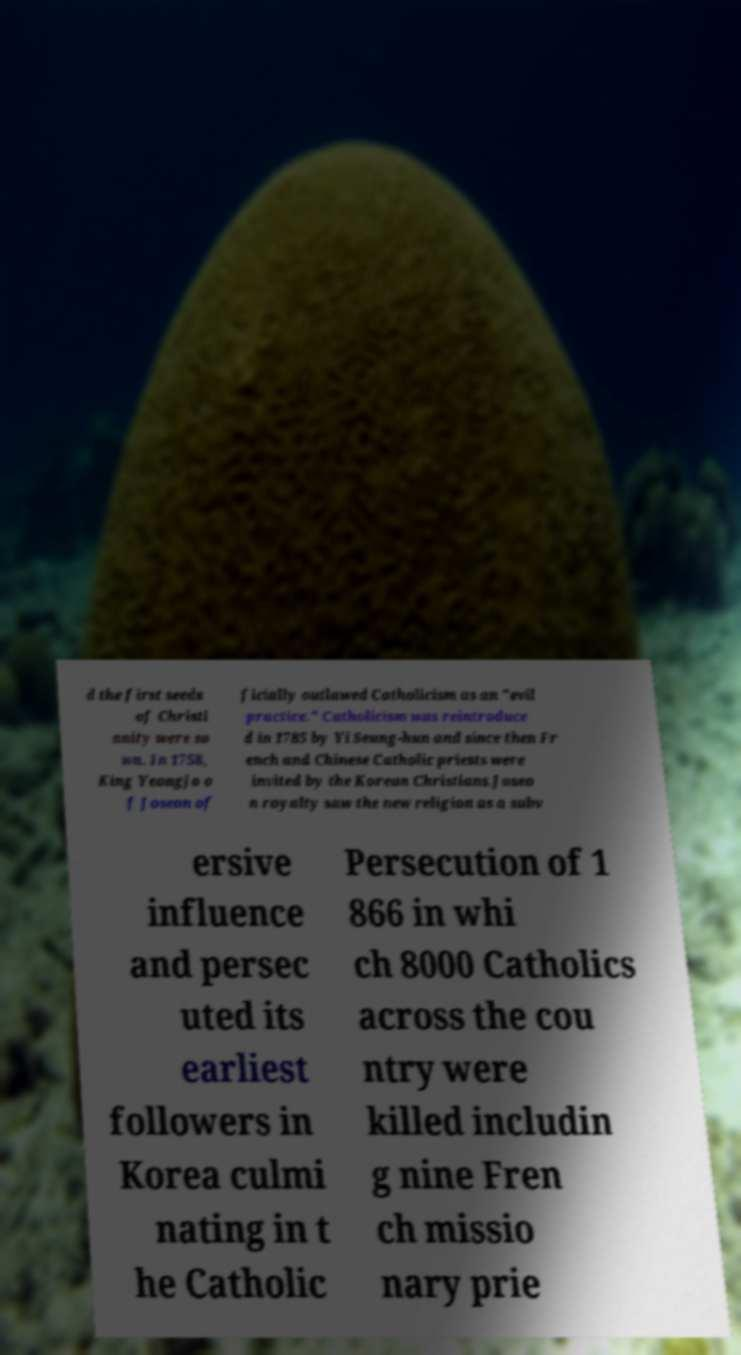Please read and relay the text visible in this image. What does it say? d the first seeds of Christi anity were so wn. In 1758, King Yeongjo o f Joseon of ficially outlawed Catholicism as an "evil practice." Catholicism was reintroduce d in 1785 by Yi Seung-hun and since then Fr ench and Chinese Catholic priests were invited by the Korean Christians.Joseo n royalty saw the new religion as a subv ersive influence and persec uted its earliest followers in Korea culmi nating in t he Catholic Persecution of 1 866 in whi ch 8000 Catholics across the cou ntry were killed includin g nine Fren ch missio nary prie 